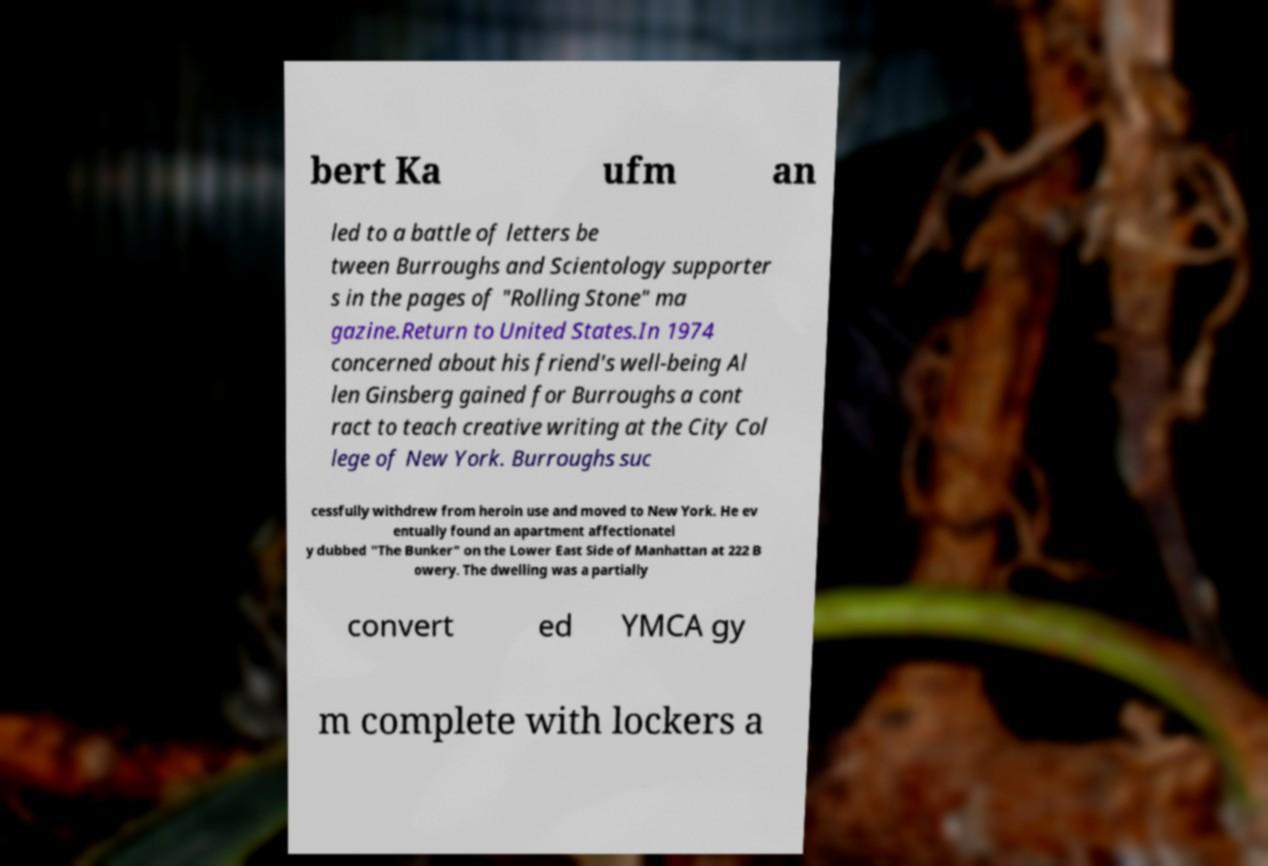Could you assist in decoding the text presented in this image and type it out clearly? bert Ka ufm an led to a battle of letters be tween Burroughs and Scientology supporter s in the pages of "Rolling Stone" ma gazine.Return to United States.In 1974 concerned about his friend's well-being Al len Ginsberg gained for Burroughs a cont ract to teach creative writing at the City Col lege of New York. Burroughs suc cessfully withdrew from heroin use and moved to New York. He ev entually found an apartment affectionatel y dubbed "The Bunker" on the Lower East Side of Manhattan at 222 B owery. The dwelling was a partially convert ed YMCA gy m complete with lockers a 